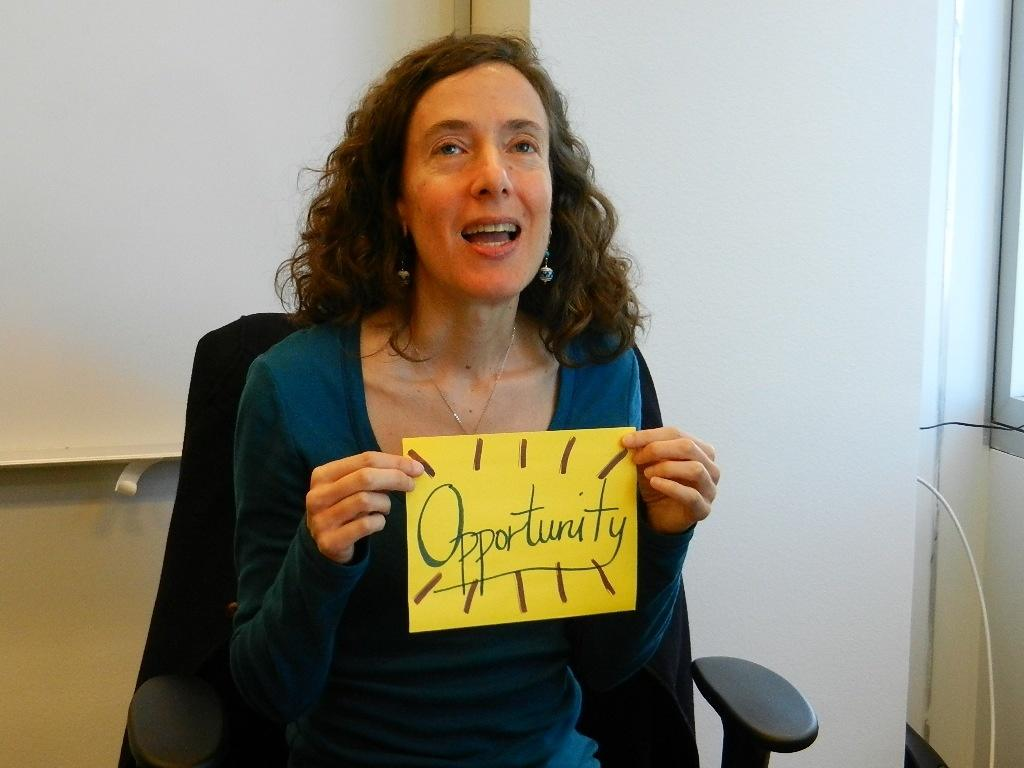Who is present in the image? There is a woman in the image. What is the woman doing in the image? The woman is sitting on a chair in the image. What is the woman holding in the image? The woman is holding a paper in the image. What is the color of the paper? The paper is white. What type of record can be seen playing on the turntable in the image? There is no record or turntable present in the image; it features a woman sitting on a chair holding a white paper. Can you see a tiger in the image? There is no tiger present in the image. 